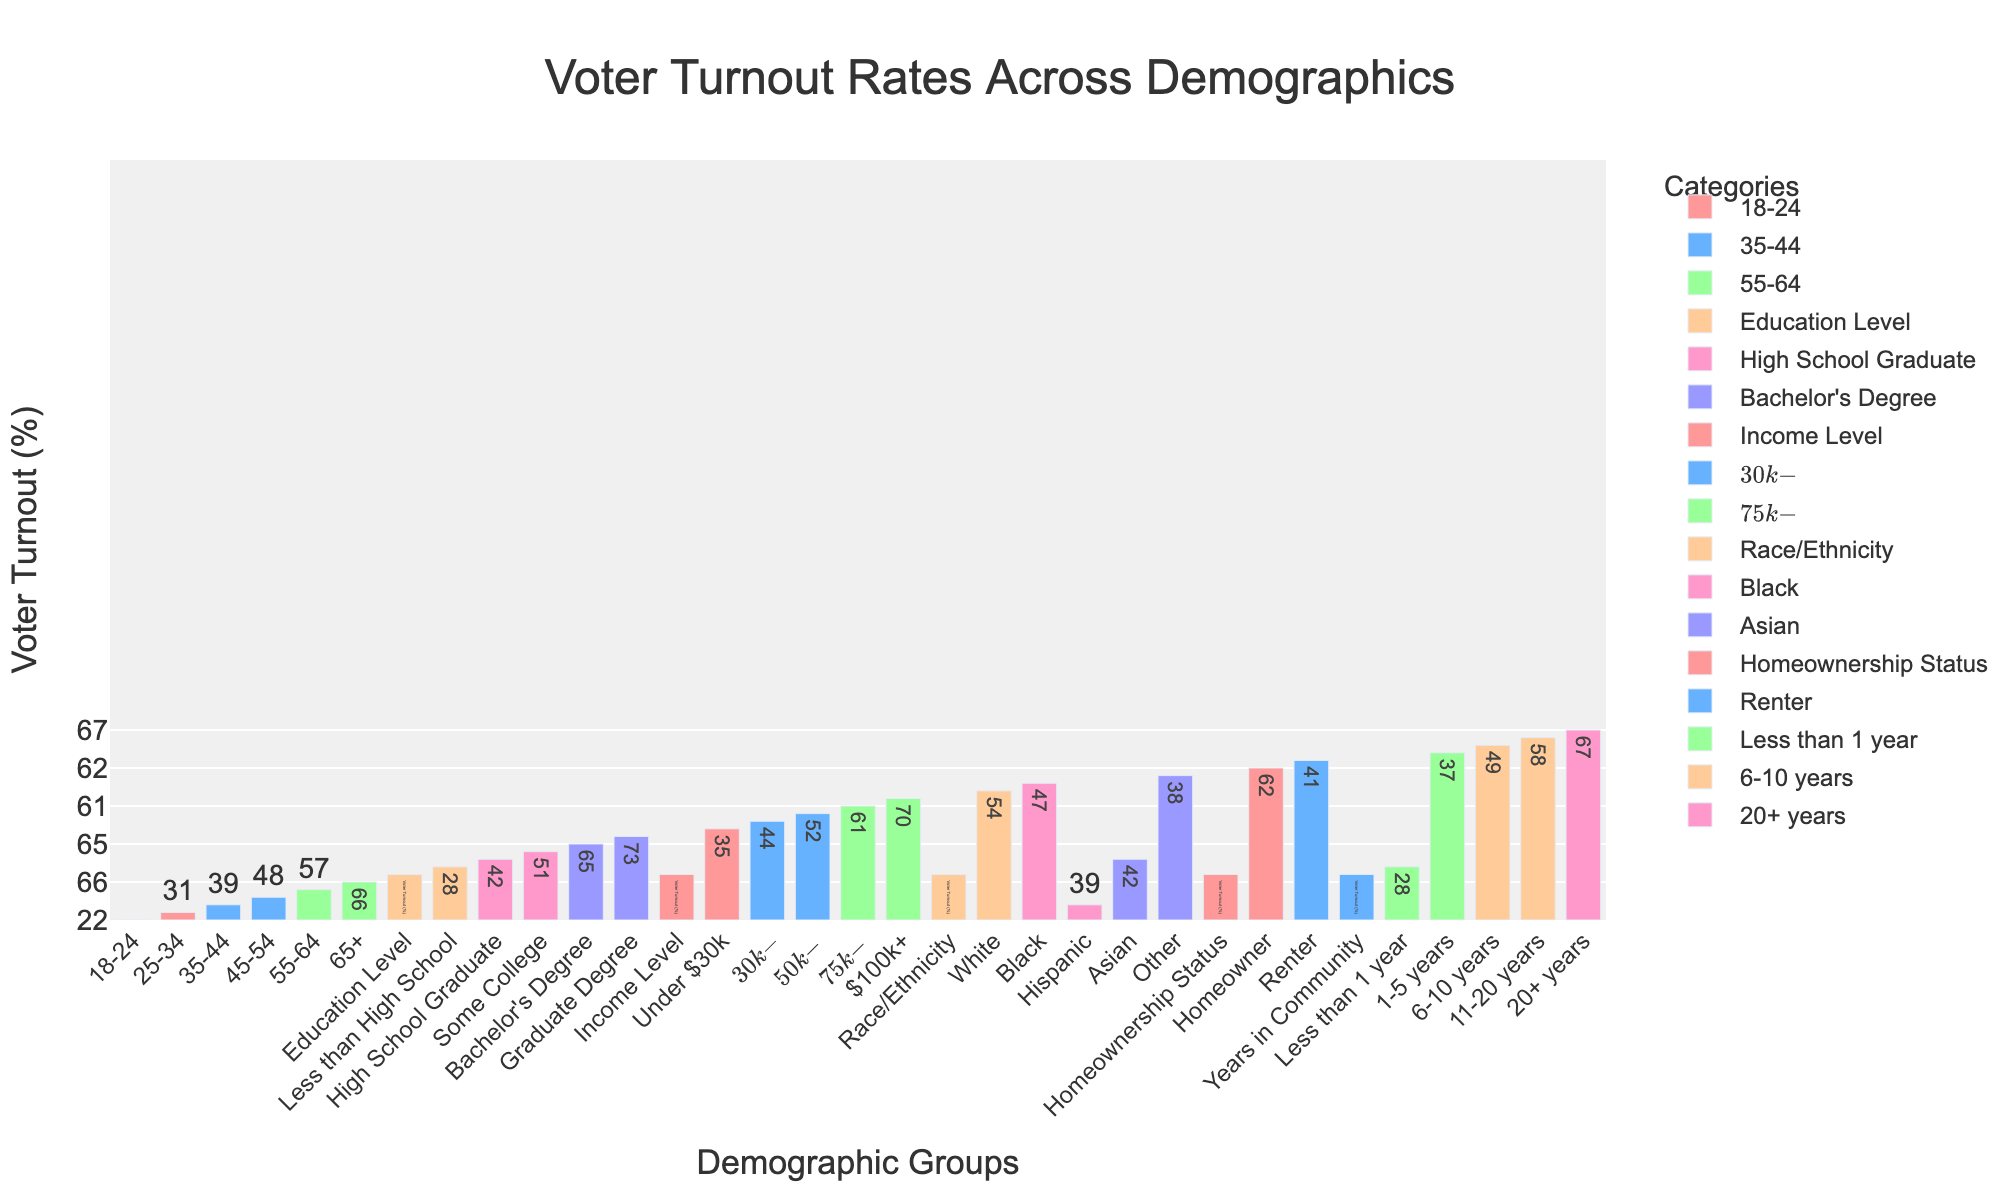Which age group has the highest voter turnout? By looking at the 'Age Group' category in the bar chart, the bar representing '65+' is the tallest, indicating the highest voter turnout of 66%.
Answer: 65+ Which group among Homeowners and Renters has a higher voter turnout? The 'Homeowner' bar is visibly taller than the 'Renter' bar, indicating a higher voter turnout of 62% compared to 41%.
Answer: Homeowner What is the voter turnout difference between those with a Bachelor's Degree and those with a Graduate Degree? The bar for those with a Bachelor's Degree shows a voter turnout of 65%, and the bar for those with a Graduate Degree shows 73%. The difference is 73% - 65% = 8%.
Answer: 8% What is the median voter turnout for the different income levels? The voter turnout rates are 35%, 44%, 52%, 61%, and 70%. The median is the middle value when the numbers are arranged in ascending order, which is 52%.
Answer: 52% Which income level has the closest voter turnout rate compared to the average across all age groups? First, calculate the average voter turnout for all age groups: (22 + 31 + 39 + 48 + 57 + 66) / 6 = 43.83%. The income level 'Under $30k' has a 35% turnout, '30k-$50k' has 44%, '50k-$75k' has 52%, '75k-$100k' has 61%, and '$100k+' has 70%. The '30k-$50k' level is closest to 43.83%.
Answer: $30k-$50k What is the range of voter turnout percentages across different educational levels? The highest voter turnout percentage is for those with a Graduate Degree (73%), and the lowest is for those with less than a High School education (28%). The range is 73% - 28% = 45%.
Answer: 45% Which demographic has the lowest voter turnout rate, and what is the percentage? By examining all categories, the lowest voter turnout rate is for the '18-24' age group, with a turnout of 22%.
Answer: 18-24, 22% What is the total voter turnout rate for people who have spent more than 10 years in the community? For '11-20 years', voter turnout is 58%, and for '20+ years', it is 67%. Summing these gives 58% + 67% = 125%.
Answer: 125% How does the voter turnout of Black individuals compare with that of White individuals? The bar for 'Black' shows a voter turnout of 47%, whereas the bar for 'White' shows a turnout of 54%. The difference is 54% - 47% = 7%.
Answer: 7% higher Which demographic within Age Group showed an improvement of exactly 9% from one age category to the next? From the chart: '18-24' to '25-34' shows an increase of 31% - 22% = 9%. None of the other age categories in the group show an exactly 9% increase.
Answer: '18-24' to '25-34' 